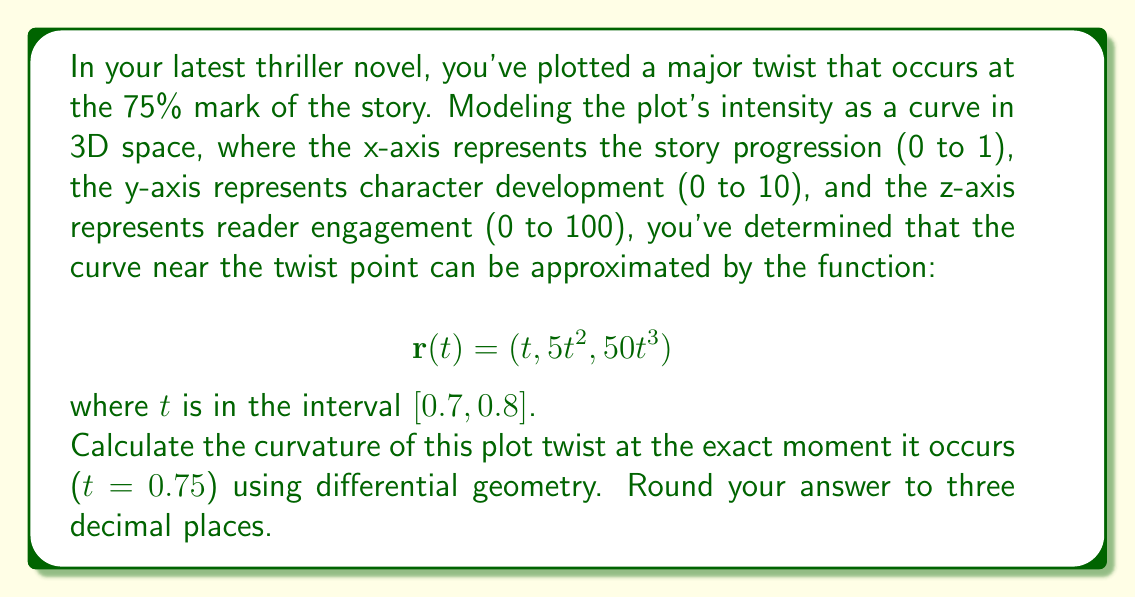Could you help me with this problem? To calculate the curvature of the plot twist, we'll use the formula for the curvature of a parametric curve in 3D space:

$$\kappa = \frac{|\mathbf{r}'(t) \times \mathbf{r}''(t)|}{|\mathbf{r}'(t)|^3}$$

Step 1: Calculate $\mathbf{r}'(t)$
$$\mathbf{r}'(t) = (1, 10t, 150t^2)$$

Step 2: Calculate $\mathbf{r}''(t)$
$$\mathbf{r}''(t) = (0, 10, 300t)$$

Step 3: Calculate $\mathbf{r}'(t) \times \mathbf{r}''(t)$
$$\mathbf{r}'(t) \times \mathbf{r}''(t) = (3000t^3 - 1500t^2, -300t, 10)$$

Step 4: Calculate $|\mathbf{r}'(t) \times \mathbf{r}''(t)|$ at $t = 0.75$
$$|\mathbf{r}'(0.75) \times \mathbf{r}''(0.75)| = \sqrt{(3000(0.75)^3 - 1500(0.75)^2)^2 + (-300(0.75))^2 + 10^2} \approx 648.244$$

Step 5: Calculate $|\mathbf{r}'(t)|$ at $t = 0.75$
$$|\mathbf{r}'(0.75)| = \sqrt{1^2 + (10(0.75))^2 + (150(0.75)^2)^2} \approx 71.367$$

Step 6: Apply the curvature formula
$$\kappa = \frac{648.244}{71.367^3} \approx 0.00178$$

Step 7: Round to three decimal places
$$\kappa \approx 0.002$$
Answer: $0.002$ 